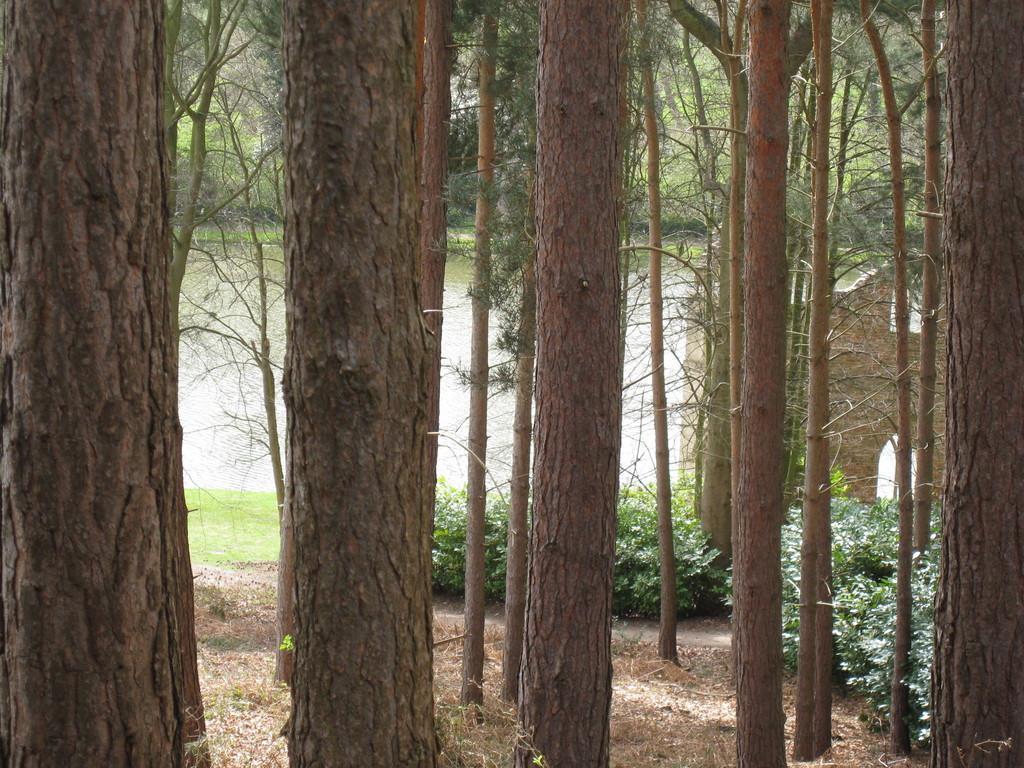Could you give a brief overview of what you see in this image? In this image there are trees, plants and river. 